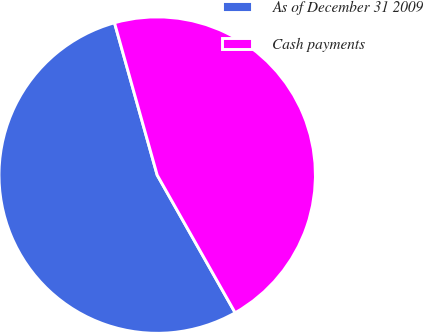Convert chart. <chart><loc_0><loc_0><loc_500><loc_500><pie_chart><fcel>As of December 31 2009<fcel>Cash payments<nl><fcel>53.85%<fcel>46.15%<nl></chart> 